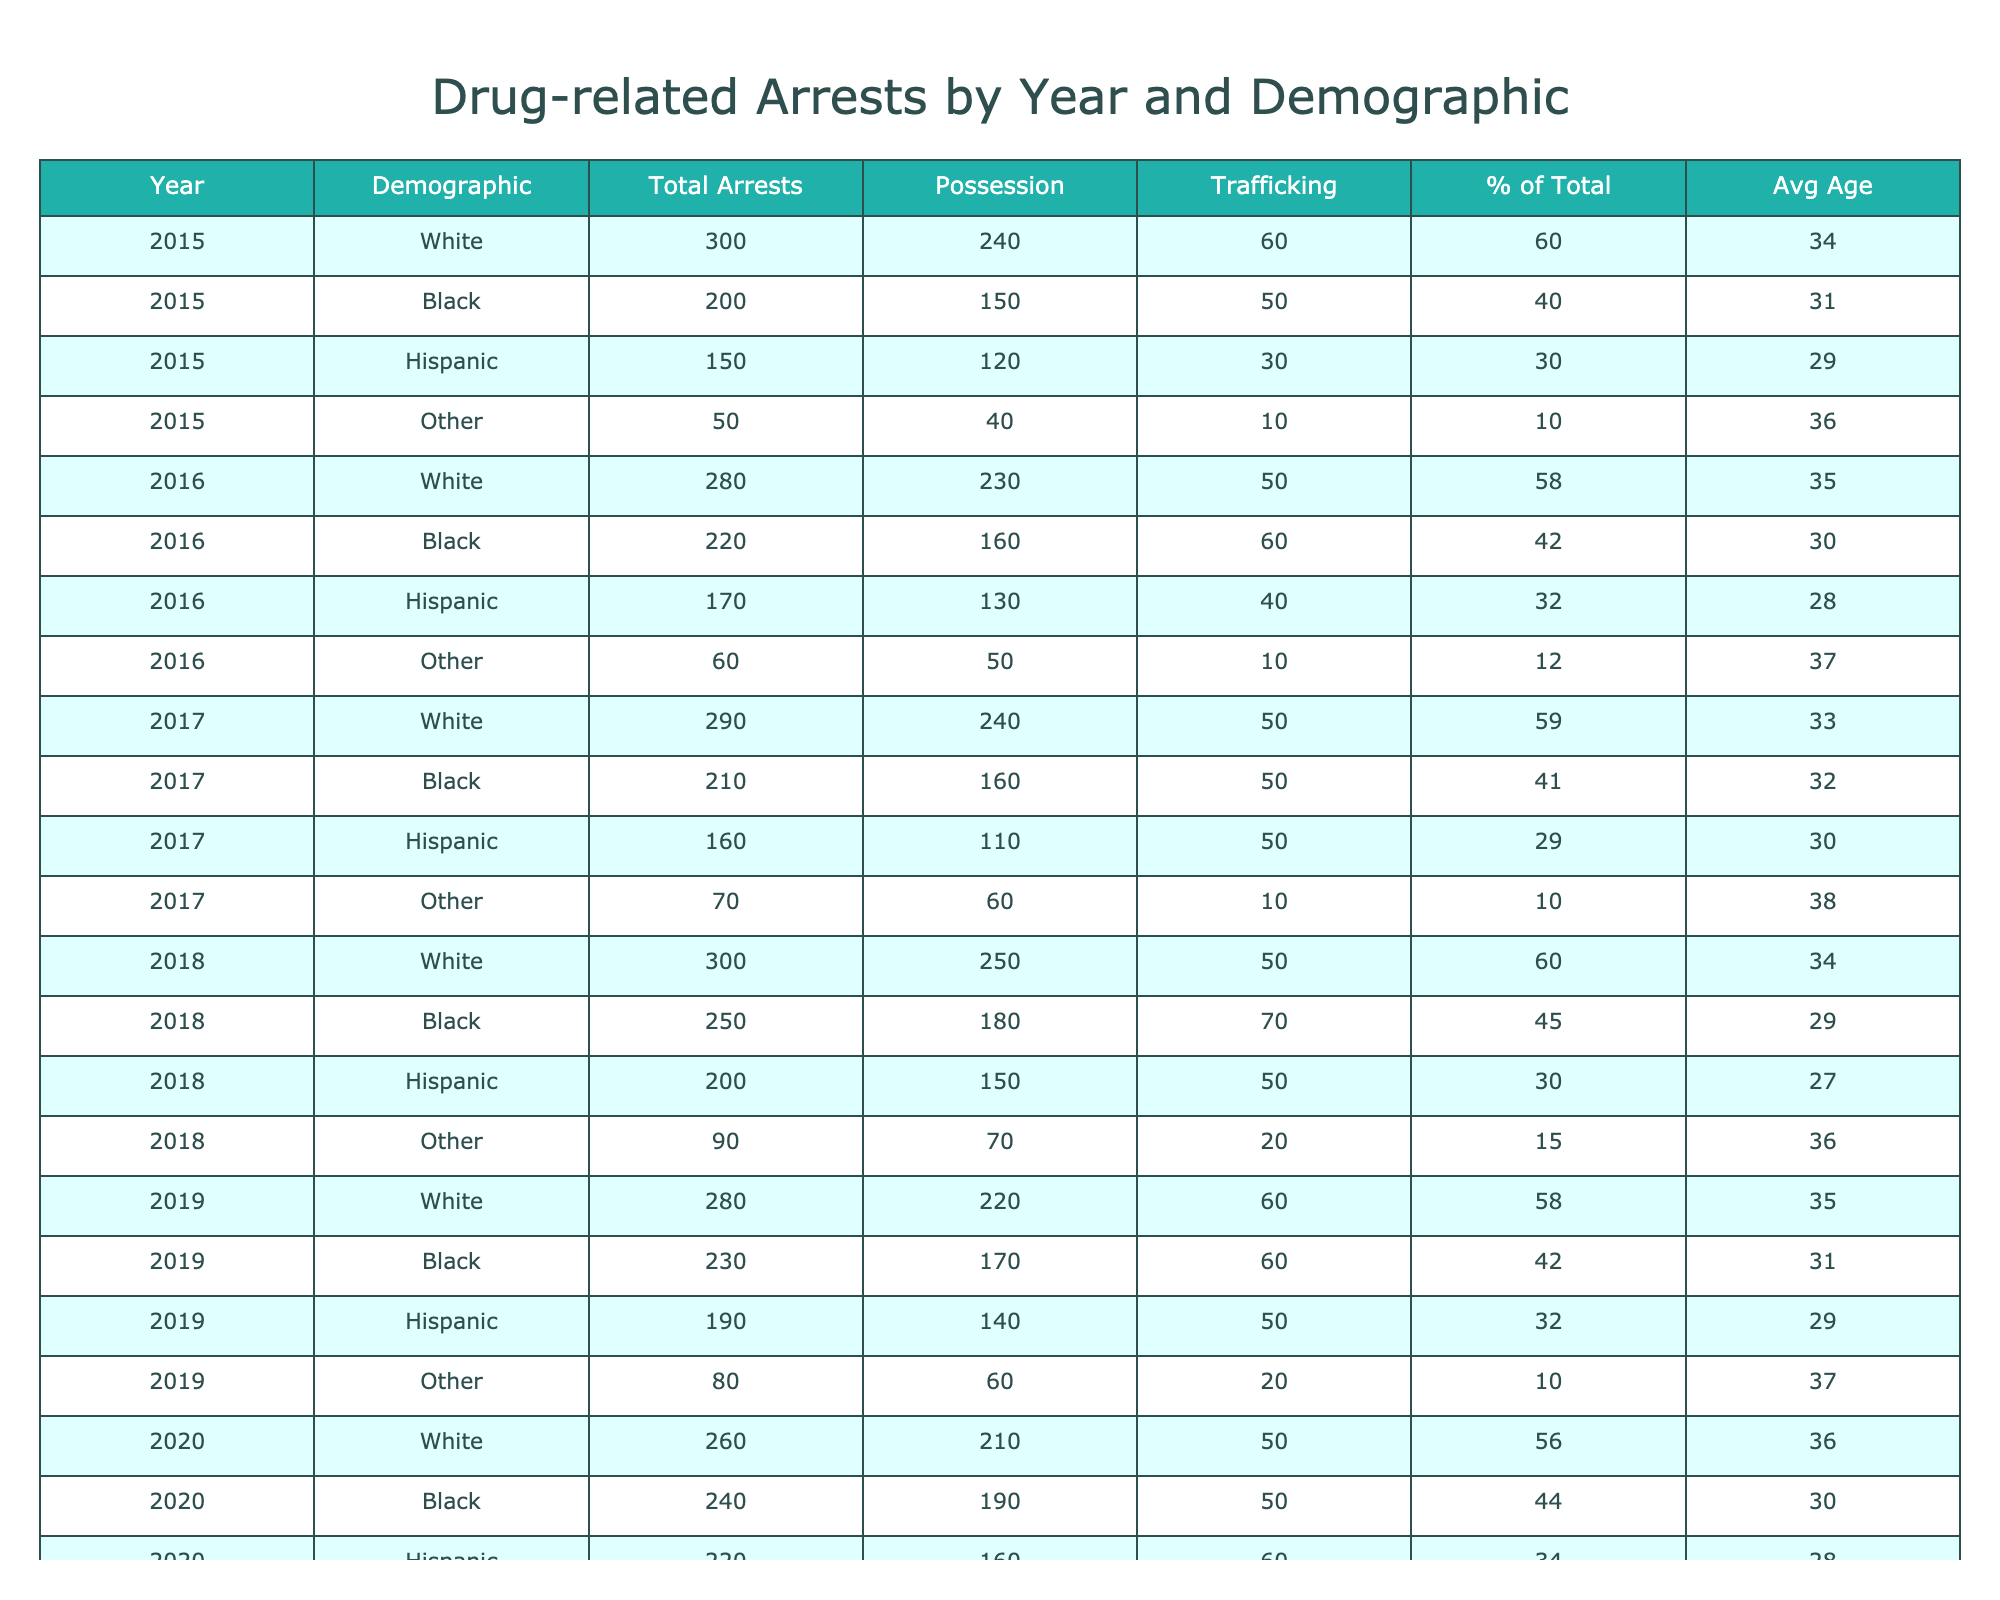What was the total number of arrests for Black individuals in 2020? In the table, under the year 2020 and for the demographic "Black," the total number of arrests is 240.
Answer: 240 What percentage of total arrests in 2019 were for possession among Hispanics? In 2019 for Hispanics, the arrests for possession were 140 out of a total of 190. The percentage is calculated as (140/190) * 100 = 73.68%.
Answer: Approximately 73.7% What is the average age of individuals arrested in 2021? The average ages listed for the year 2021 are: White 37, Black 32, Hispanic 28, and Other 40. To calculate the average: (37 + 32 + 28 + 40) / 4 = 34.25, rounding gives an average age of 34.
Answer: Approximately 34 In which year did the demographic "Other" have the highest total arrests? Looking through the total arrests for the "Other" demographic, the highest value is 120 in 2023.
Answer: 2023 Was there an increase or decrease in total arrests for White individuals from 2018 to 2019? The total arrests for White individuals were 300 in 2018 and 280 in 2019, showing a decrease.
Answer: Decrease What was the difference in total arrests between Black and White individuals in 2022? For 2022, White individuals had 270 total arrests, while Black individuals had 240. The difference is 270 - 240 = 30.
Answer: 30 Which demographic had the lowest percentage of total arrests in 2015? In 2015, the demographic "Other" had the lowest percentage of total arrests at 10%.
Answer: 10% What demographic showed the highest average age among those arrested in 2017? In 2017, the average ages are: White 33, Black 32, Hispanic 30, and Other 38. Thus, "Other" showed the highest average age.
Answer: Other How many total arrests were there across all demographics in 2016? The total arrests for 2016 are: 280 (White) + 220 (Black) + 170 (Hispanic) + 60 (Other) = 730.
Answer: 730 Was the number of trafficking arrests higher for Black individuals than Hispanic individuals in 2019? In 2019, Black individuals had 60 trafficking arrests, while Hispanic individuals had 50, making it true that Black individuals had more.
Answer: Yes 